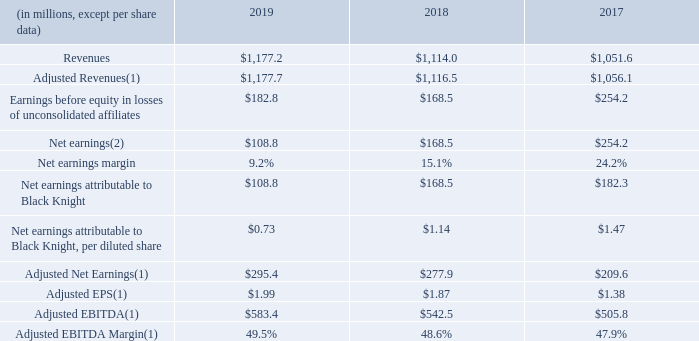(1) For a description and reconciliation of non-GAAP financial measures presented in this document, please see the Non-GAAP Financial Measures page, or visit the Black Knight Investor Relations website at https://investor.blackknightinc.com.
(2) In 2019, the effect of our indirect investment in The Dun and Bradstreet Corporation was a reduction of Net earnings of $73.9 million primarily due to the effect of its purchase accounting adjustments, restructuring charges and other non-operating charges. In 2017, Net earnings includes a one-time, non-cash net tax benefit of $110.9 million related to the revaluation of our deferred income tax assets and liabilities as a result of the Tax Cuts and Jobs Act of 2017 (the “Tax Reform Act”).
What was the effect of the company's indirect investment in The Dun and Bradstreet Corporation? A reduction of net earnings of $73.9 million primarily due to the effect of its purchase accounting adjustments, restructuring charges and other non-operating charges. What was the revenues in 2018?
Answer scale should be: million. 1,114.0. What were the net earnings in 2017?
Answer scale should be: million. 254.2. What was the change in net earnings between 2017 and 2018?
Answer scale should be: million. 168.5-254.2
Answer: -85.7. What was the percentage change in the Net earnings margin between 2017 and 2019?
Answer scale should be: percent. 9.2-24.2
Answer: -15. What was the percentage change in revenues between 2018 and 2019?
Answer scale should be: percent. (1,177.2-1,114.0)/1,114.0
Answer: 5.67. 